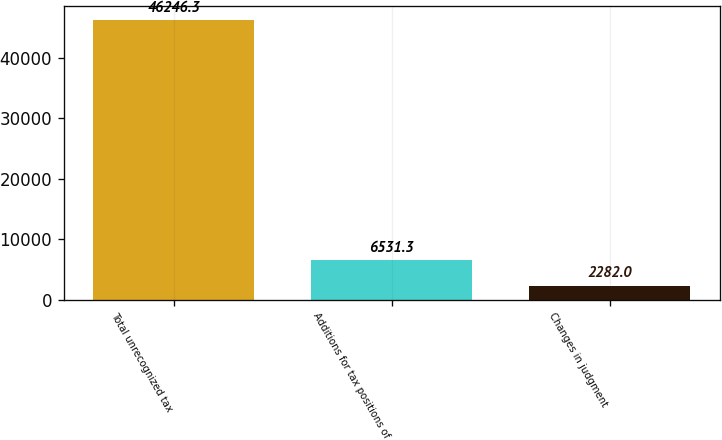Convert chart. <chart><loc_0><loc_0><loc_500><loc_500><bar_chart><fcel>Total unrecognized tax<fcel>Additions for tax positions of<fcel>Changes in judgment<nl><fcel>46246.3<fcel>6531.3<fcel>2282<nl></chart> 